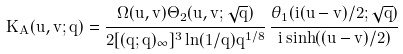<formula> <loc_0><loc_0><loc_500><loc_500>K _ { A } ( u , v ; q ) = \frac { \Omega ( u , v ) \Theta _ { 2 } ( u , v ; \sqrt { q } ) } { 2 [ ( q ; q ) _ { \infty } ] ^ { 3 } \ln ( 1 / q ) q ^ { 1 / 8 } } \, \frac { \theta _ { 1 } ( i ( u - v ) / 2 ; \sqrt { q } ) } { i \sinh ( ( u - v ) / 2 ) }</formula> 